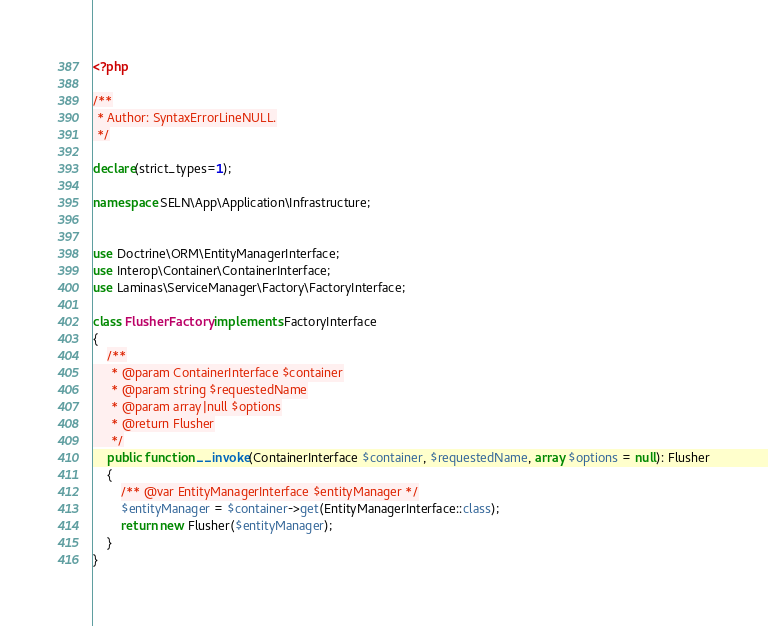<code> <loc_0><loc_0><loc_500><loc_500><_PHP_><?php

/**
 * Author: SyntaxErrorLineNULL.
 */

declare(strict_types=1);

namespace SELN\App\Application\Infrastructure;


use Doctrine\ORM\EntityManagerInterface;
use Interop\Container\ContainerInterface;
use Laminas\ServiceManager\Factory\FactoryInterface;

class FlusherFactory implements FactoryInterface
{
    /**
     * @param ContainerInterface $container
     * @param string $requestedName
     * @param array|null $options
     * @return Flusher
     */
    public function __invoke(ContainerInterface $container, $requestedName, array $options = null): Flusher
    {
        /** @var EntityManagerInterface $entityManager */
        $entityManager = $container->get(EntityManagerInterface::class);
        return new Flusher($entityManager);
    }
}</code> 